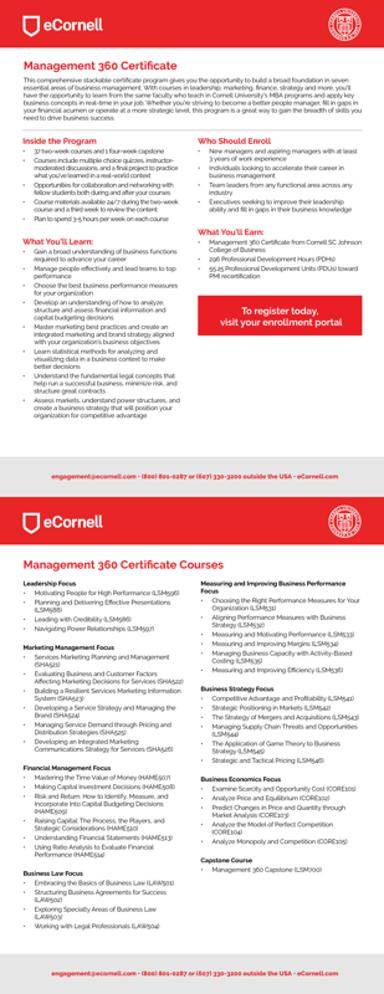Can you tell me more about the 'Business Strategy Focus' course mentioned in the image? 'Business Strategy Focus' is a course designed to help managers develop and refine strategies that drive competitive advantage and profitability. Key topics include strategic analysis methods, strategic leadership, and the implementation of strategy in business operations. What skills can participants expect to gain from this course? Participants can expect to gain skills in strategic thinking, effective decision-making, and leadership in strategy implementation. These skills are vital for navigating complex business landscapes and for achieving sustainable business success. 